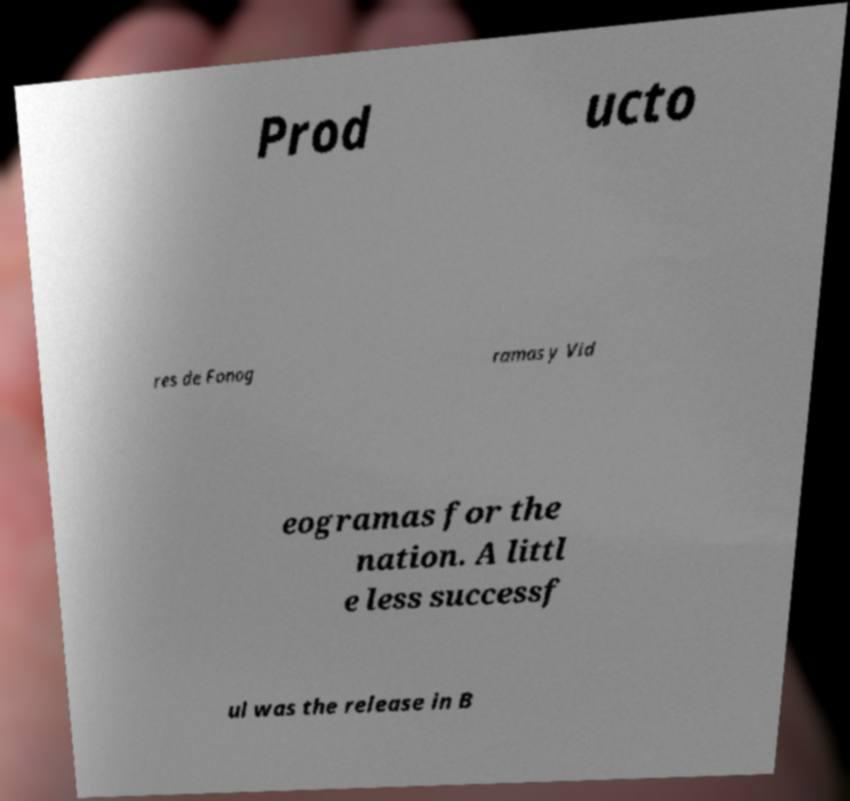What messages or text are displayed in this image? I need them in a readable, typed format. Prod ucto res de Fonog ramas y Vid eogramas for the nation. A littl e less successf ul was the release in B 